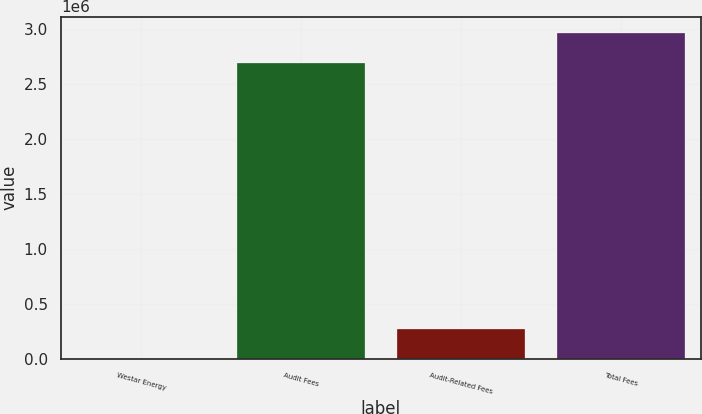Convert chart. <chart><loc_0><loc_0><loc_500><loc_500><bar_chart><fcel>Westar Energy<fcel>Audit Fees<fcel>Audit-Related Fees<fcel>Total Fees<nl><fcel>2017<fcel>2.691e+06<fcel>276315<fcel>2.9653e+06<nl></chart> 